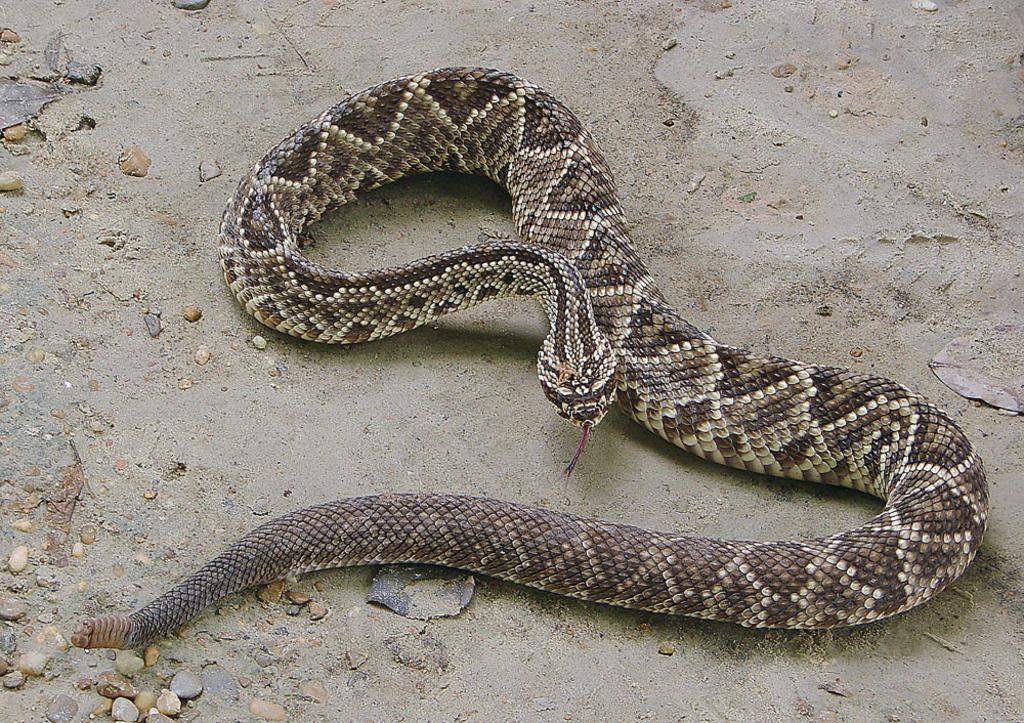Please provide a concise description of this image. In the image in the center, we can see one snake, which is in black, ash and white color. 